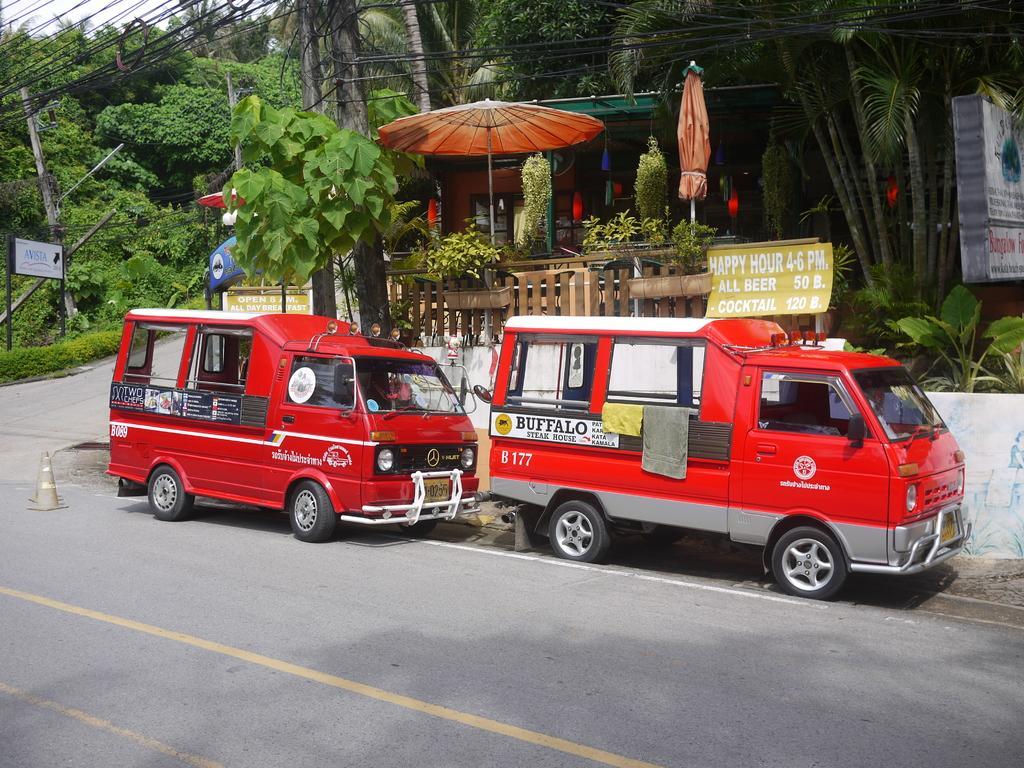Could you give a brief overview of what you see in this image? In this image I can see two vehicles which are in red color on the road. Background I can see two umbrellas in brown color, trees in green color and sky in white color. 